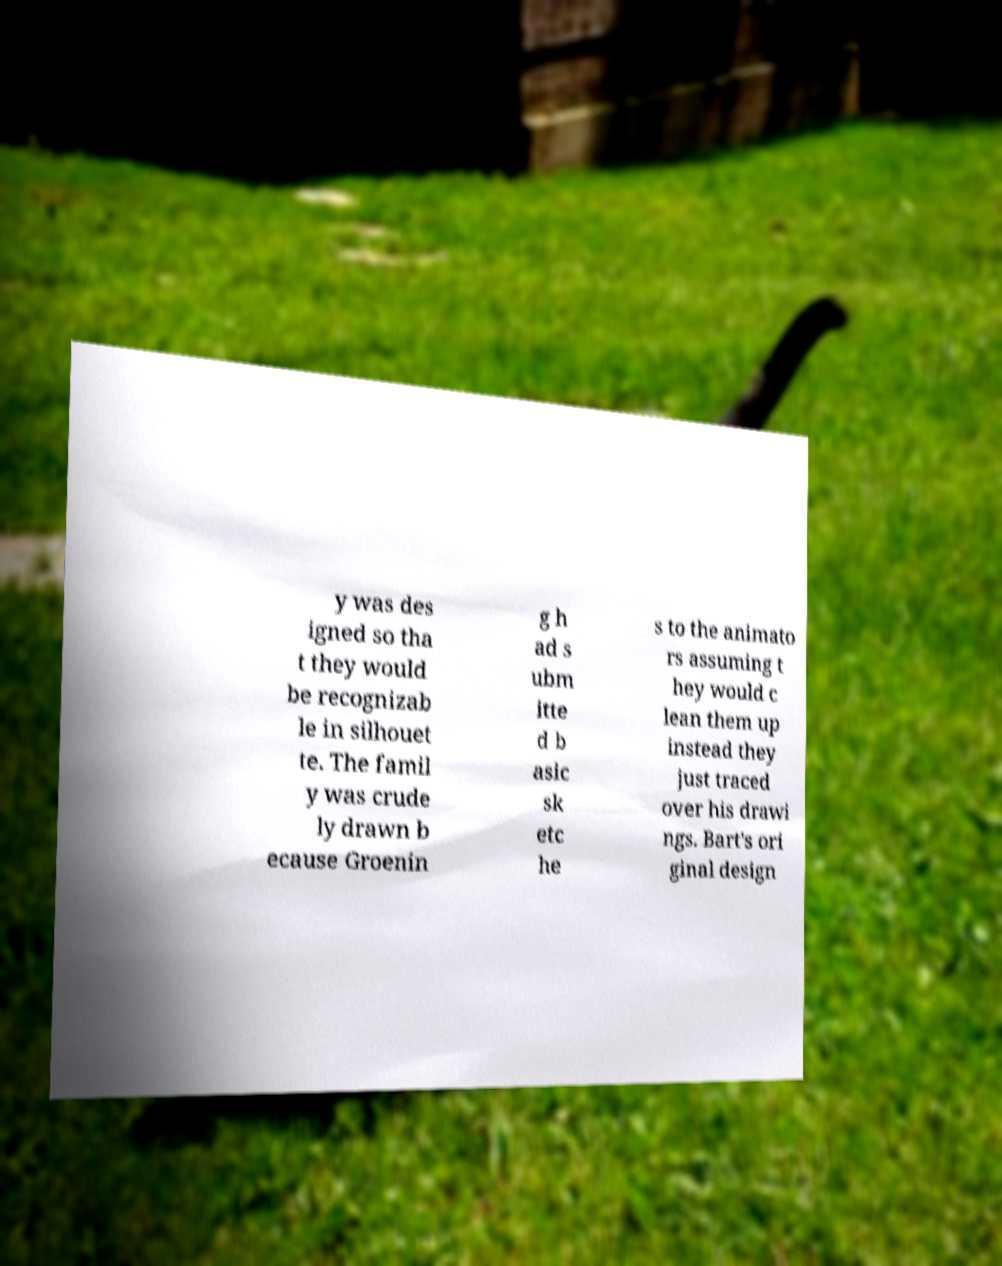Could you extract and type out the text from this image? y was des igned so tha t they would be recognizab le in silhouet te. The famil y was crude ly drawn b ecause Groenin g h ad s ubm itte d b asic sk etc he s to the animato rs assuming t hey would c lean them up instead they just traced over his drawi ngs. Bart's ori ginal design 